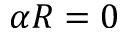Convert formula to latex. <formula><loc_0><loc_0><loc_500><loc_500>\alpha R = 0</formula> 